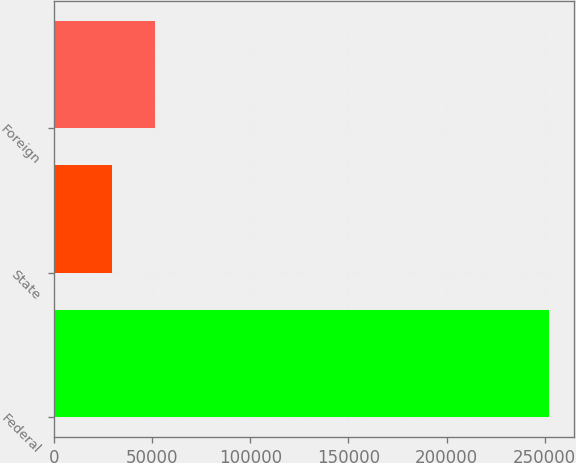Convert chart to OTSL. <chart><loc_0><loc_0><loc_500><loc_500><bar_chart><fcel>Federal<fcel>State<fcel>Foreign<nl><fcel>252337<fcel>29288<fcel>51592.9<nl></chart> 